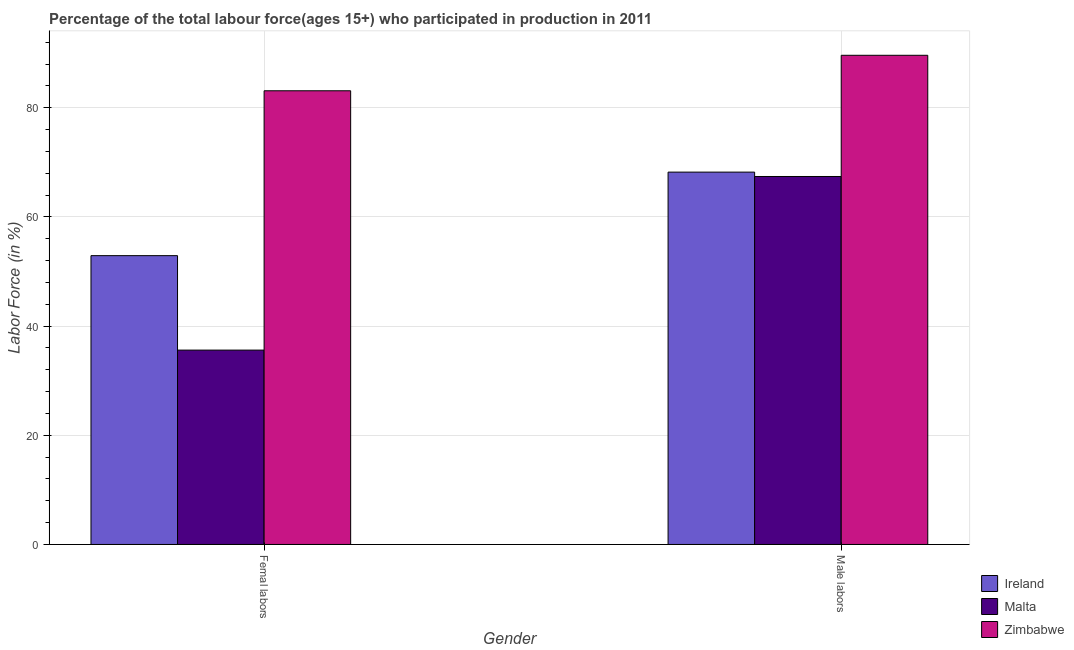How many groups of bars are there?
Make the answer very short. 2. Are the number of bars per tick equal to the number of legend labels?
Your response must be concise. Yes. How many bars are there on the 2nd tick from the right?
Your answer should be compact. 3. What is the label of the 2nd group of bars from the left?
Provide a succinct answer. Male labors. What is the percentage of male labour force in Ireland?
Make the answer very short. 68.2. Across all countries, what is the maximum percentage of female labor force?
Offer a terse response. 83.1. Across all countries, what is the minimum percentage of male labour force?
Provide a succinct answer. 67.4. In which country was the percentage of male labour force maximum?
Ensure brevity in your answer.  Zimbabwe. In which country was the percentage of female labor force minimum?
Provide a short and direct response. Malta. What is the total percentage of male labour force in the graph?
Offer a terse response. 225.2. What is the difference between the percentage of female labor force in Ireland and that in Zimbabwe?
Make the answer very short. -30.2. What is the difference between the percentage of female labor force in Zimbabwe and the percentage of male labour force in Ireland?
Give a very brief answer. 14.9. What is the average percentage of female labor force per country?
Make the answer very short. 57.2. What is the difference between the percentage of female labor force and percentage of male labour force in Ireland?
Your response must be concise. -15.3. In how many countries, is the percentage of female labor force greater than 32 %?
Your answer should be compact. 3. What is the ratio of the percentage of female labor force in Malta to that in Ireland?
Offer a terse response. 0.67. What does the 1st bar from the left in Femal labors represents?
Ensure brevity in your answer.  Ireland. What does the 3rd bar from the right in Femal labors represents?
Your answer should be very brief. Ireland. How many bars are there?
Your response must be concise. 6. How many countries are there in the graph?
Make the answer very short. 3. Where does the legend appear in the graph?
Make the answer very short. Bottom right. How are the legend labels stacked?
Ensure brevity in your answer.  Vertical. What is the title of the graph?
Your answer should be compact. Percentage of the total labour force(ages 15+) who participated in production in 2011. What is the label or title of the Y-axis?
Make the answer very short. Labor Force (in %). What is the Labor Force (in %) in Ireland in Femal labors?
Your answer should be compact. 52.9. What is the Labor Force (in %) in Malta in Femal labors?
Your answer should be compact. 35.6. What is the Labor Force (in %) of Zimbabwe in Femal labors?
Make the answer very short. 83.1. What is the Labor Force (in %) in Ireland in Male labors?
Keep it short and to the point. 68.2. What is the Labor Force (in %) in Malta in Male labors?
Keep it short and to the point. 67.4. What is the Labor Force (in %) in Zimbabwe in Male labors?
Make the answer very short. 89.6. Across all Gender, what is the maximum Labor Force (in %) of Ireland?
Give a very brief answer. 68.2. Across all Gender, what is the maximum Labor Force (in %) of Malta?
Your answer should be compact. 67.4. Across all Gender, what is the maximum Labor Force (in %) of Zimbabwe?
Provide a succinct answer. 89.6. Across all Gender, what is the minimum Labor Force (in %) in Ireland?
Keep it short and to the point. 52.9. Across all Gender, what is the minimum Labor Force (in %) of Malta?
Provide a short and direct response. 35.6. Across all Gender, what is the minimum Labor Force (in %) in Zimbabwe?
Provide a succinct answer. 83.1. What is the total Labor Force (in %) of Ireland in the graph?
Your answer should be very brief. 121.1. What is the total Labor Force (in %) in Malta in the graph?
Provide a succinct answer. 103. What is the total Labor Force (in %) of Zimbabwe in the graph?
Ensure brevity in your answer.  172.7. What is the difference between the Labor Force (in %) in Ireland in Femal labors and that in Male labors?
Your answer should be compact. -15.3. What is the difference between the Labor Force (in %) in Malta in Femal labors and that in Male labors?
Offer a very short reply. -31.8. What is the difference between the Labor Force (in %) of Ireland in Femal labors and the Labor Force (in %) of Malta in Male labors?
Offer a terse response. -14.5. What is the difference between the Labor Force (in %) in Ireland in Femal labors and the Labor Force (in %) in Zimbabwe in Male labors?
Keep it short and to the point. -36.7. What is the difference between the Labor Force (in %) in Malta in Femal labors and the Labor Force (in %) in Zimbabwe in Male labors?
Make the answer very short. -54. What is the average Labor Force (in %) in Ireland per Gender?
Your answer should be compact. 60.55. What is the average Labor Force (in %) of Malta per Gender?
Your answer should be compact. 51.5. What is the average Labor Force (in %) of Zimbabwe per Gender?
Your answer should be very brief. 86.35. What is the difference between the Labor Force (in %) in Ireland and Labor Force (in %) in Malta in Femal labors?
Keep it short and to the point. 17.3. What is the difference between the Labor Force (in %) in Ireland and Labor Force (in %) in Zimbabwe in Femal labors?
Provide a short and direct response. -30.2. What is the difference between the Labor Force (in %) of Malta and Labor Force (in %) of Zimbabwe in Femal labors?
Your response must be concise. -47.5. What is the difference between the Labor Force (in %) in Ireland and Labor Force (in %) in Zimbabwe in Male labors?
Your answer should be very brief. -21.4. What is the difference between the Labor Force (in %) of Malta and Labor Force (in %) of Zimbabwe in Male labors?
Provide a short and direct response. -22.2. What is the ratio of the Labor Force (in %) of Ireland in Femal labors to that in Male labors?
Your response must be concise. 0.78. What is the ratio of the Labor Force (in %) of Malta in Femal labors to that in Male labors?
Your answer should be compact. 0.53. What is the ratio of the Labor Force (in %) in Zimbabwe in Femal labors to that in Male labors?
Give a very brief answer. 0.93. What is the difference between the highest and the second highest Labor Force (in %) of Malta?
Offer a very short reply. 31.8. What is the difference between the highest and the lowest Labor Force (in %) of Ireland?
Your answer should be very brief. 15.3. What is the difference between the highest and the lowest Labor Force (in %) in Malta?
Offer a terse response. 31.8. What is the difference between the highest and the lowest Labor Force (in %) of Zimbabwe?
Offer a very short reply. 6.5. 